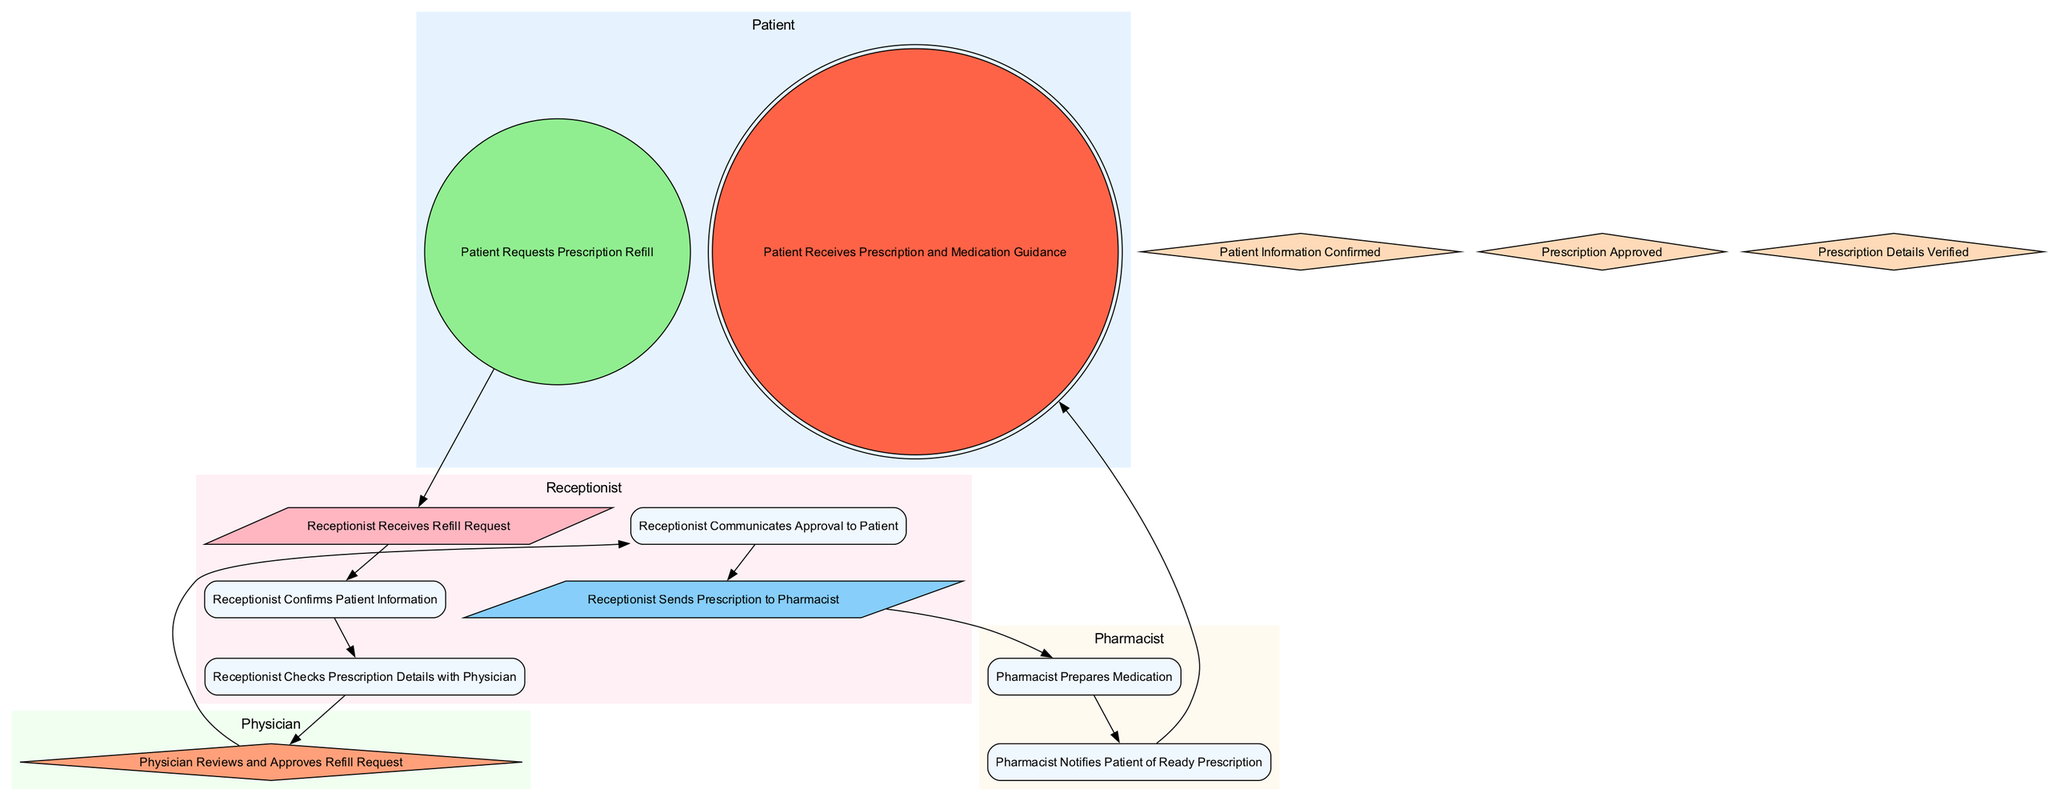What is the initial activity in the diagram? The initial activity is the first step in the flow, which is "Patient Requests Prescription Refill." It indicates where the process begins.
Answer: Patient Requests Prescription Refill How many actors are present in the diagram? By counting the unique roles in the actor section of the diagram, we find four actors: Patient, Receptionist, Pharmacist, and Physician.
Answer: Four What is the final activity in the diagram? The final activity is the last step in the flow, which is "Patient Receives Prescription and Medication Guidance," marking the completion of the process.
Answer: Patient Receives Prescription and Medication Guidance Who processes the refill request after the receptionist checks prescription details? The next step after the receptionist checks the details involves the Physician, who reviews and approves the refill request as indicated in the decision node.
Answer: Physician What happens if the prescription is not approved? If the prescription is not approved, the flow does not show a specific next step for this outcome, which indicates that the process likely ends or reverts back to another state not detailed in this diagram.
Answer: Ends What type of activity does the pharmacist perform? The pharmacist's roles in the diagram are categorized as process activities where they prepare the medication and notify the patient, which are ongoing tasks in the workflow.
Answer: Process What condition must be met before the receptionist communicates with the patient? The condition that must be met is "Prescription Approved." This is a prerequisite for the receptionist to communicate approval to the patient.
Answer: Prescription Approved How many conditions are included in the diagram? By analyzing the conditions listed, we find three distinct conditions that are integrated into the process flow of the activity diagram.
Answer: Three Which actor is responsible for confirming patient information? The actor responsible for this task is the Receptionist, as it directly follows the activity where the patient submits the refill request.
Answer: Receptionist 